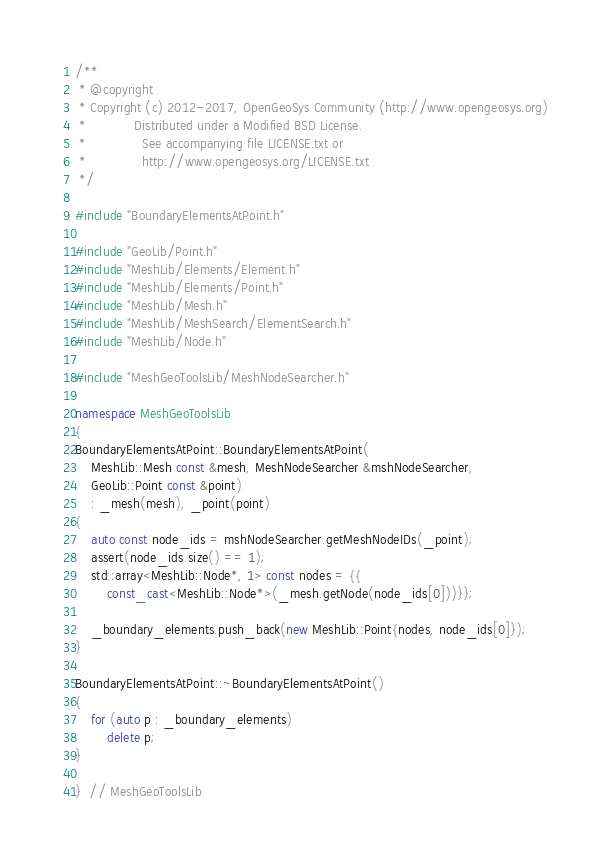Convert code to text. <code><loc_0><loc_0><loc_500><loc_500><_C++_>/**
 * @copyright
 * Copyright (c) 2012-2017, OpenGeoSys Community (http://www.opengeosys.org)
 *            Distributed under a Modified BSD License.
 *              See accompanying file LICENSE.txt or
 *              http://www.opengeosys.org/LICENSE.txt
 */

#include "BoundaryElementsAtPoint.h"

#include "GeoLib/Point.h"
#include "MeshLib/Elements/Element.h"
#include "MeshLib/Elements/Point.h"
#include "MeshLib/Mesh.h"
#include "MeshLib/MeshSearch/ElementSearch.h"
#include "MeshLib/Node.h"

#include "MeshGeoToolsLib/MeshNodeSearcher.h"

namespace MeshGeoToolsLib
{
BoundaryElementsAtPoint::BoundaryElementsAtPoint(
    MeshLib::Mesh const &mesh, MeshNodeSearcher &mshNodeSearcher,
    GeoLib::Point const &point)
    : _mesh(mesh), _point(point)
{
    auto const node_ids = mshNodeSearcher.getMeshNodeIDs(_point);
    assert(node_ids.size() == 1);
    std::array<MeshLib::Node*, 1> const nodes = {{
        const_cast<MeshLib::Node*>(_mesh.getNode(node_ids[0]))}};

    _boundary_elements.push_back(new MeshLib::Point{nodes, node_ids[0]});
}

BoundaryElementsAtPoint::~BoundaryElementsAtPoint()
{
    for (auto p : _boundary_elements)
        delete p;
}

}  // MeshGeoToolsLib
</code> 